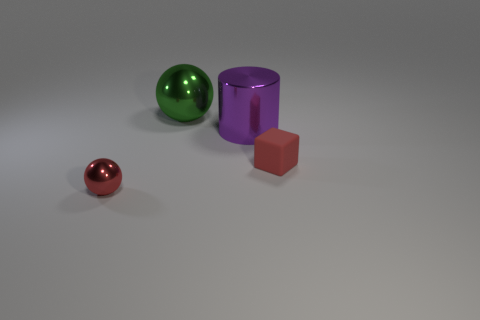Subtract all blue cylinders. Subtract all red blocks. How many cylinders are left? 1 Subtract all yellow cylinders. How many yellow blocks are left? 0 Add 1 cyans. How many purples exist? 0 Subtract all spheres. Subtract all large metal balls. How many objects are left? 1 Add 1 rubber things. How many rubber things are left? 2 Add 4 brown matte spheres. How many brown matte spheres exist? 4 Add 1 tiny metallic balls. How many objects exist? 5 Subtract all red balls. How many balls are left? 1 Subtract 0 green blocks. How many objects are left? 4 Subtract all cubes. How many objects are left? 3 